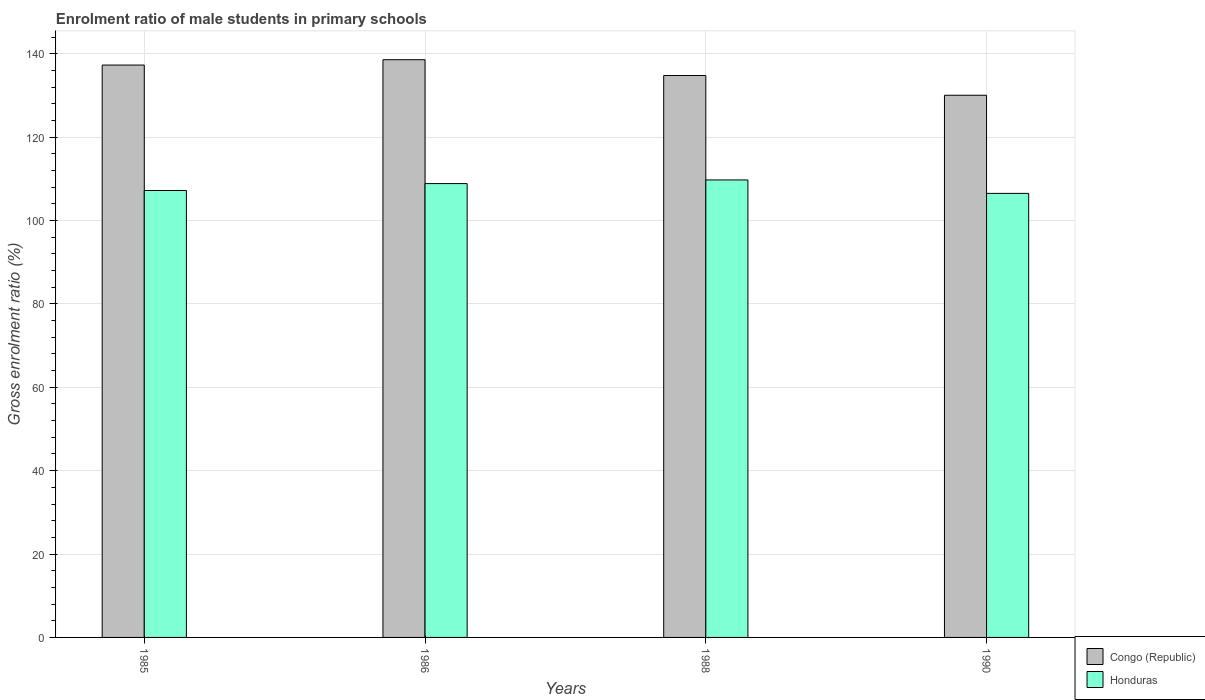How many different coloured bars are there?
Your response must be concise. 2. How many bars are there on the 3rd tick from the left?
Keep it short and to the point. 2. What is the label of the 3rd group of bars from the left?
Give a very brief answer. 1988. What is the enrolment ratio of male students in primary schools in Congo (Republic) in 1988?
Your response must be concise. 134.79. Across all years, what is the maximum enrolment ratio of male students in primary schools in Congo (Republic)?
Provide a short and direct response. 138.58. Across all years, what is the minimum enrolment ratio of male students in primary schools in Congo (Republic)?
Provide a succinct answer. 130.06. In which year was the enrolment ratio of male students in primary schools in Honduras minimum?
Your answer should be very brief. 1990. What is the total enrolment ratio of male students in primary schools in Congo (Republic) in the graph?
Your answer should be very brief. 540.72. What is the difference between the enrolment ratio of male students in primary schools in Honduras in 1985 and that in 1988?
Provide a succinct answer. -2.53. What is the difference between the enrolment ratio of male students in primary schools in Honduras in 1986 and the enrolment ratio of male students in primary schools in Congo (Republic) in 1985?
Provide a short and direct response. -28.43. What is the average enrolment ratio of male students in primary schools in Congo (Republic) per year?
Provide a succinct answer. 135.18. In the year 1985, what is the difference between the enrolment ratio of male students in primary schools in Honduras and enrolment ratio of male students in primary schools in Congo (Republic)?
Make the answer very short. -30.09. What is the ratio of the enrolment ratio of male students in primary schools in Honduras in 1986 to that in 1988?
Keep it short and to the point. 0.99. Is the enrolment ratio of male students in primary schools in Honduras in 1986 less than that in 1990?
Offer a very short reply. No. What is the difference between the highest and the second highest enrolment ratio of male students in primary schools in Congo (Republic)?
Provide a succinct answer. 1.28. What is the difference between the highest and the lowest enrolment ratio of male students in primary schools in Congo (Republic)?
Keep it short and to the point. 8.52. In how many years, is the enrolment ratio of male students in primary schools in Honduras greater than the average enrolment ratio of male students in primary schools in Honduras taken over all years?
Give a very brief answer. 2. What does the 1st bar from the left in 1985 represents?
Provide a succinct answer. Congo (Republic). What does the 1st bar from the right in 1990 represents?
Your answer should be compact. Honduras. Are all the bars in the graph horizontal?
Ensure brevity in your answer.  No. How many years are there in the graph?
Your response must be concise. 4. What is the difference between two consecutive major ticks on the Y-axis?
Keep it short and to the point. 20. Does the graph contain grids?
Offer a very short reply. Yes. Where does the legend appear in the graph?
Make the answer very short. Bottom right. What is the title of the graph?
Make the answer very short. Enrolment ratio of male students in primary schools. What is the label or title of the Y-axis?
Your answer should be compact. Gross enrolment ratio (%). What is the Gross enrolment ratio (%) in Congo (Republic) in 1985?
Your answer should be compact. 137.3. What is the Gross enrolment ratio (%) in Honduras in 1985?
Your answer should be very brief. 107.2. What is the Gross enrolment ratio (%) of Congo (Republic) in 1986?
Your answer should be compact. 138.58. What is the Gross enrolment ratio (%) of Honduras in 1986?
Your answer should be compact. 108.87. What is the Gross enrolment ratio (%) in Congo (Republic) in 1988?
Keep it short and to the point. 134.79. What is the Gross enrolment ratio (%) in Honduras in 1988?
Make the answer very short. 109.74. What is the Gross enrolment ratio (%) in Congo (Republic) in 1990?
Offer a very short reply. 130.06. What is the Gross enrolment ratio (%) in Honduras in 1990?
Keep it short and to the point. 106.51. Across all years, what is the maximum Gross enrolment ratio (%) of Congo (Republic)?
Your response must be concise. 138.58. Across all years, what is the maximum Gross enrolment ratio (%) in Honduras?
Keep it short and to the point. 109.74. Across all years, what is the minimum Gross enrolment ratio (%) of Congo (Republic)?
Offer a terse response. 130.06. Across all years, what is the minimum Gross enrolment ratio (%) in Honduras?
Provide a short and direct response. 106.51. What is the total Gross enrolment ratio (%) in Congo (Republic) in the graph?
Your answer should be very brief. 540.72. What is the total Gross enrolment ratio (%) in Honduras in the graph?
Your response must be concise. 432.32. What is the difference between the Gross enrolment ratio (%) of Congo (Republic) in 1985 and that in 1986?
Provide a short and direct response. -1.28. What is the difference between the Gross enrolment ratio (%) of Honduras in 1985 and that in 1986?
Keep it short and to the point. -1.66. What is the difference between the Gross enrolment ratio (%) in Congo (Republic) in 1985 and that in 1988?
Offer a terse response. 2.51. What is the difference between the Gross enrolment ratio (%) in Honduras in 1985 and that in 1988?
Make the answer very short. -2.53. What is the difference between the Gross enrolment ratio (%) of Congo (Republic) in 1985 and that in 1990?
Offer a terse response. 7.24. What is the difference between the Gross enrolment ratio (%) in Honduras in 1985 and that in 1990?
Give a very brief answer. 0.69. What is the difference between the Gross enrolment ratio (%) in Congo (Republic) in 1986 and that in 1988?
Make the answer very short. 3.79. What is the difference between the Gross enrolment ratio (%) in Honduras in 1986 and that in 1988?
Ensure brevity in your answer.  -0.87. What is the difference between the Gross enrolment ratio (%) in Congo (Republic) in 1986 and that in 1990?
Your answer should be compact. 8.52. What is the difference between the Gross enrolment ratio (%) in Honduras in 1986 and that in 1990?
Your answer should be compact. 2.35. What is the difference between the Gross enrolment ratio (%) of Congo (Republic) in 1988 and that in 1990?
Make the answer very short. 4.73. What is the difference between the Gross enrolment ratio (%) in Honduras in 1988 and that in 1990?
Keep it short and to the point. 3.22. What is the difference between the Gross enrolment ratio (%) in Congo (Republic) in 1985 and the Gross enrolment ratio (%) in Honduras in 1986?
Your response must be concise. 28.43. What is the difference between the Gross enrolment ratio (%) in Congo (Republic) in 1985 and the Gross enrolment ratio (%) in Honduras in 1988?
Give a very brief answer. 27.56. What is the difference between the Gross enrolment ratio (%) in Congo (Republic) in 1985 and the Gross enrolment ratio (%) in Honduras in 1990?
Offer a very short reply. 30.78. What is the difference between the Gross enrolment ratio (%) in Congo (Republic) in 1986 and the Gross enrolment ratio (%) in Honduras in 1988?
Your response must be concise. 28.84. What is the difference between the Gross enrolment ratio (%) in Congo (Republic) in 1986 and the Gross enrolment ratio (%) in Honduras in 1990?
Keep it short and to the point. 32.07. What is the difference between the Gross enrolment ratio (%) of Congo (Republic) in 1988 and the Gross enrolment ratio (%) of Honduras in 1990?
Keep it short and to the point. 28.27. What is the average Gross enrolment ratio (%) of Congo (Republic) per year?
Provide a succinct answer. 135.18. What is the average Gross enrolment ratio (%) in Honduras per year?
Offer a very short reply. 108.08. In the year 1985, what is the difference between the Gross enrolment ratio (%) in Congo (Republic) and Gross enrolment ratio (%) in Honduras?
Offer a very short reply. 30.09. In the year 1986, what is the difference between the Gross enrolment ratio (%) in Congo (Republic) and Gross enrolment ratio (%) in Honduras?
Ensure brevity in your answer.  29.71. In the year 1988, what is the difference between the Gross enrolment ratio (%) in Congo (Republic) and Gross enrolment ratio (%) in Honduras?
Your response must be concise. 25.05. In the year 1990, what is the difference between the Gross enrolment ratio (%) in Congo (Republic) and Gross enrolment ratio (%) in Honduras?
Provide a short and direct response. 23.54. What is the ratio of the Gross enrolment ratio (%) in Honduras in 1985 to that in 1986?
Provide a succinct answer. 0.98. What is the ratio of the Gross enrolment ratio (%) of Congo (Republic) in 1985 to that in 1988?
Provide a short and direct response. 1.02. What is the ratio of the Gross enrolment ratio (%) in Honduras in 1985 to that in 1988?
Keep it short and to the point. 0.98. What is the ratio of the Gross enrolment ratio (%) of Congo (Republic) in 1985 to that in 1990?
Your answer should be compact. 1.06. What is the ratio of the Gross enrolment ratio (%) of Honduras in 1985 to that in 1990?
Provide a succinct answer. 1.01. What is the ratio of the Gross enrolment ratio (%) of Congo (Republic) in 1986 to that in 1988?
Your response must be concise. 1.03. What is the ratio of the Gross enrolment ratio (%) of Honduras in 1986 to that in 1988?
Offer a terse response. 0.99. What is the ratio of the Gross enrolment ratio (%) in Congo (Republic) in 1986 to that in 1990?
Keep it short and to the point. 1.07. What is the ratio of the Gross enrolment ratio (%) in Honduras in 1986 to that in 1990?
Offer a terse response. 1.02. What is the ratio of the Gross enrolment ratio (%) of Congo (Republic) in 1988 to that in 1990?
Offer a terse response. 1.04. What is the ratio of the Gross enrolment ratio (%) in Honduras in 1988 to that in 1990?
Provide a succinct answer. 1.03. What is the difference between the highest and the second highest Gross enrolment ratio (%) of Congo (Republic)?
Ensure brevity in your answer.  1.28. What is the difference between the highest and the second highest Gross enrolment ratio (%) in Honduras?
Provide a succinct answer. 0.87. What is the difference between the highest and the lowest Gross enrolment ratio (%) of Congo (Republic)?
Keep it short and to the point. 8.52. What is the difference between the highest and the lowest Gross enrolment ratio (%) in Honduras?
Your answer should be very brief. 3.22. 